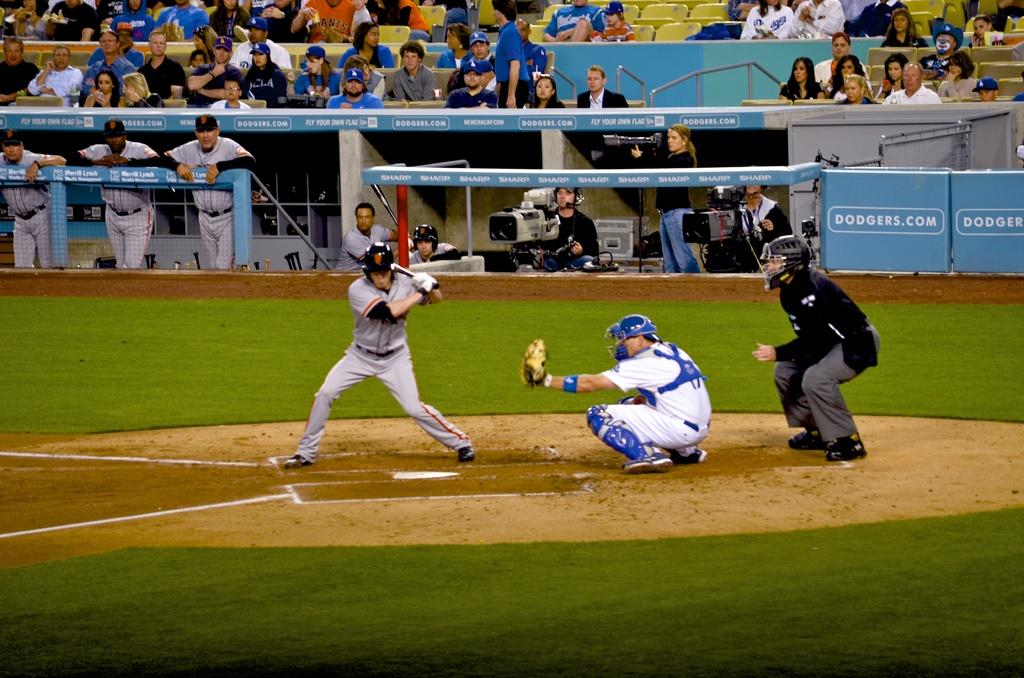<image>
Provide a brief description of the given image. Baseball game being played in a stadium with an ad which says Dodgers.com 